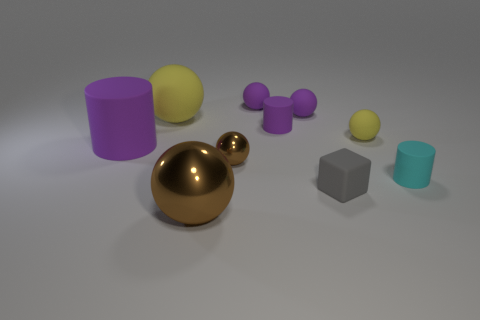Is the shape of the tiny yellow thing the same as the purple object on the left side of the big metal ball?
Make the answer very short. No. There is a brown shiny object behind the cyan object; does it have the same shape as the small cyan matte object?
Make the answer very short. No. There is another brown metallic thing that is the same shape as the big brown thing; what size is it?
Keep it short and to the point. Small. Is there any other thing that is the same size as the block?
Your answer should be very brief. Yes. Does the gray thing have the same size as the brown thing behind the tiny cyan rubber cylinder?
Your answer should be very brief. Yes. What is the shape of the purple thing in front of the small yellow object?
Your answer should be very brief. Cylinder. What color is the tiny matte cylinder on the left side of the cylinder right of the small gray matte thing?
Keep it short and to the point. Purple. There is a big metal object that is the same shape as the tiny shiny object; what color is it?
Ensure brevity in your answer.  Brown. What number of small cubes have the same color as the tiny shiny object?
Provide a short and direct response. 0. There is a large shiny object; is its color the same as the metal sphere that is to the right of the large brown metal ball?
Offer a terse response. Yes. 